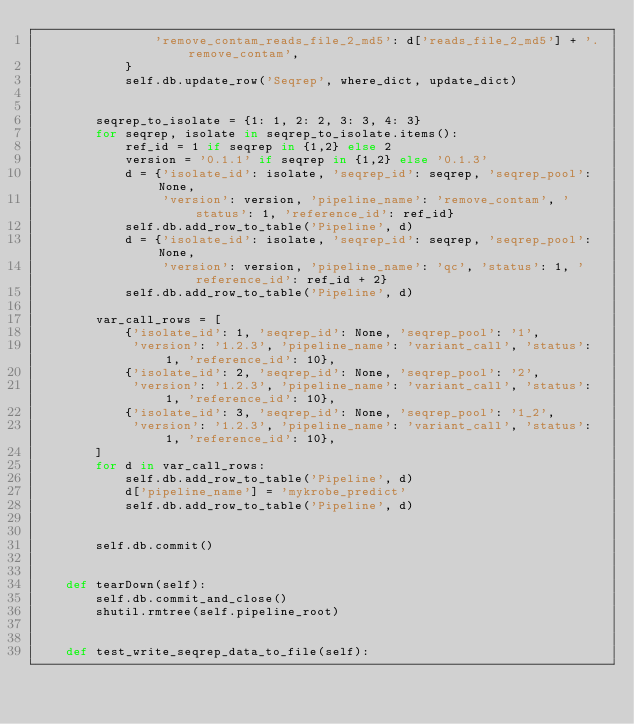<code> <loc_0><loc_0><loc_500><loc_500><_Python_>                'remove_contam_reads_file_2_md5': d['reads_file_2_md5'] + '.remove_contam',
            }
            self.db.update_row('Seqrep', where_dict, update_dict)


        seqrep_to_isolate = {1: 1, 2: 2, 3: 3, 4: 3}
        for seqrep, isolate in seqrep_to_isolate.items():
            ref_id = 1 if seqrep in {1,2} else 2
            version = '0.1.1' if seqrep in {1,2} else '0.1.3'
            d = {'isolate_id': isolate, 'seqrep_id': seqrep, 'seqrep_pool': None,
                 'version': version, 'pipeline_name': 'remove_contam', 'status': 1, 'reference_id': ref_id}
            self.db.add_row_to_table('Pipeline', d)
            d = {'isolate_id': isolate, 'seqrep_id': seqrep, 'seqrep_pool': None,
                 'version': version, 'pipeline_name': 'qc', 'status': 1, 'reference_id': ref_id + 2}
            self.db.add_row_to_table('Pipeline', d)

        var_call_rows = [
            {'isolate_id': 1, 'seqrep_id': None, 'seqrep_pool': '1',
             'version': '1.2.3', 'pipeline_name': 'variant_call', 'status': 1, 'reference_id': 10},
            {'isolate_id': 2, 'seqrep_id': None, 'seqrep_pool': '2',
             'version': '1.2.3', 'pipeline_name': 'variant_call', 'status': 1, 'reference_id': 10},
            {'isolate_id': 3, 'seqrep_id': None, 'seqrep_pool': '1_2',
             'version': '1.2.3', 'pipeline_name': 'variant_call', 'status': 1, 'reference_id': 10},
        ]
        for d in var_call_rows:
            self.db.add_row_to_table('Pipeline', d)
            d['pipeline_name'] = 'mykrobe_predict'
            self.db.add_row_to_table('Pipeline', d)


        self.db.commit()


    def tearDown(self):
        self.db.commit_and_close()
        shutil.rmtree(self.pipeline_root)


    def test_write_seqrep_data_to_file(self):</code> 